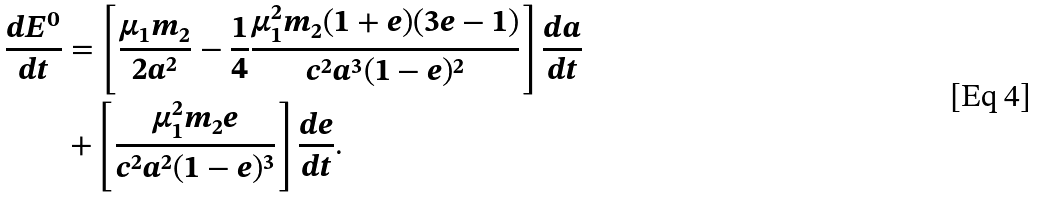<formula> <loc_0><loc_0><loc_500><loc_500>\frac { d E ^ { 0 } } { d t } & = \left [ \frac { \mu _ { 1 } m _ { 2 } } { 2 a ^ { 2 } } - \frac { 1 } { 4 } \frac { \mu _ { 1 } ^ { 2 } m _ { 2 } ( 1 + e ) ( 3 e - 1 ) } { c ^ { 2 } a ^ { 3 } ( 1 - e ) ^ { 2 } } \right ] \frac { d a } { d t } \\ & + \left [ \frac { \mu _ { 1 } ^ { 2 } m _ { 2 } e } { c ^ { 2 } a ^ { 2 } ( 1 - e ) ^ { 3 } } \right ] \frac { d e } { d t } .</formula> 